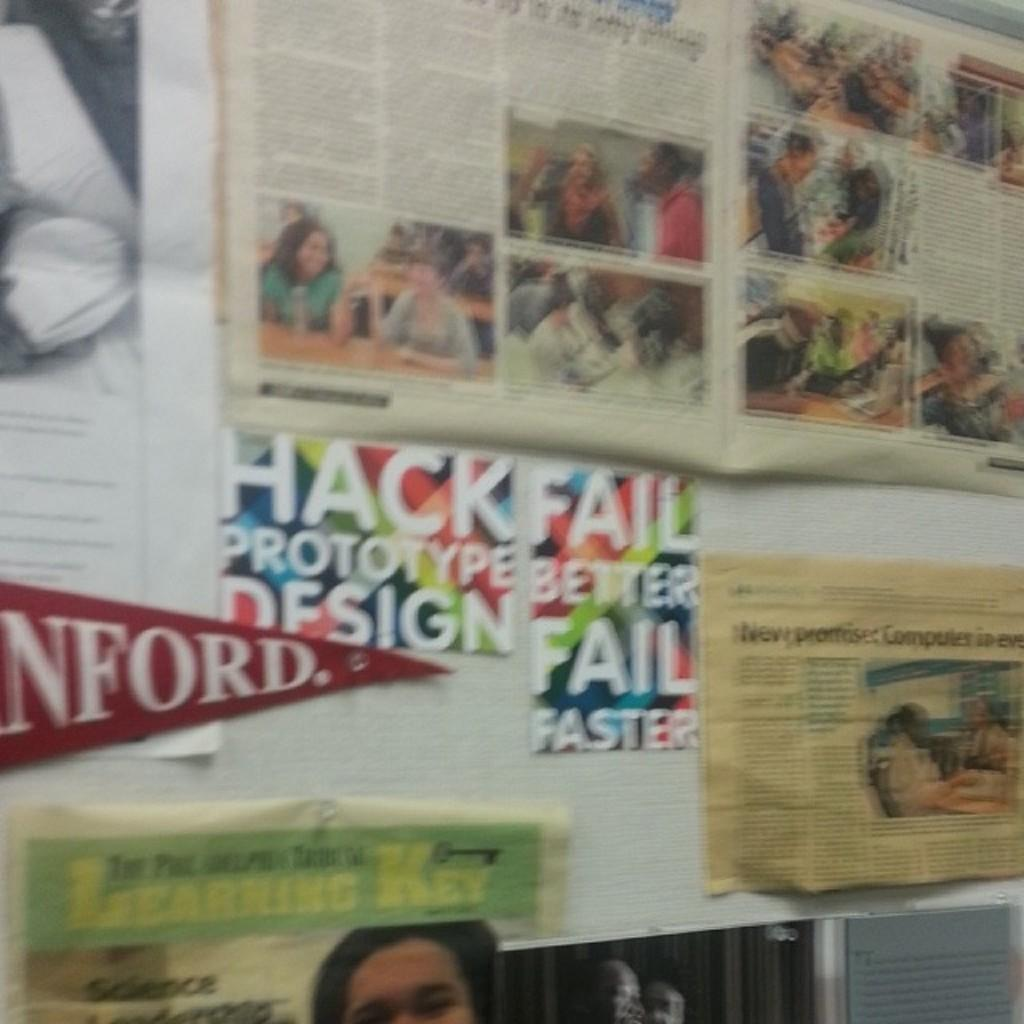<image>
Write a terse but informative summary of the picture. Poster on the wall that says Hack Fail prototype better design fail faster. 